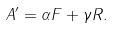<formula> <loc_0><loc_0><loc_500><loc_500>A ^ { \prime } = \alpha F + \gamma R .</formula> 